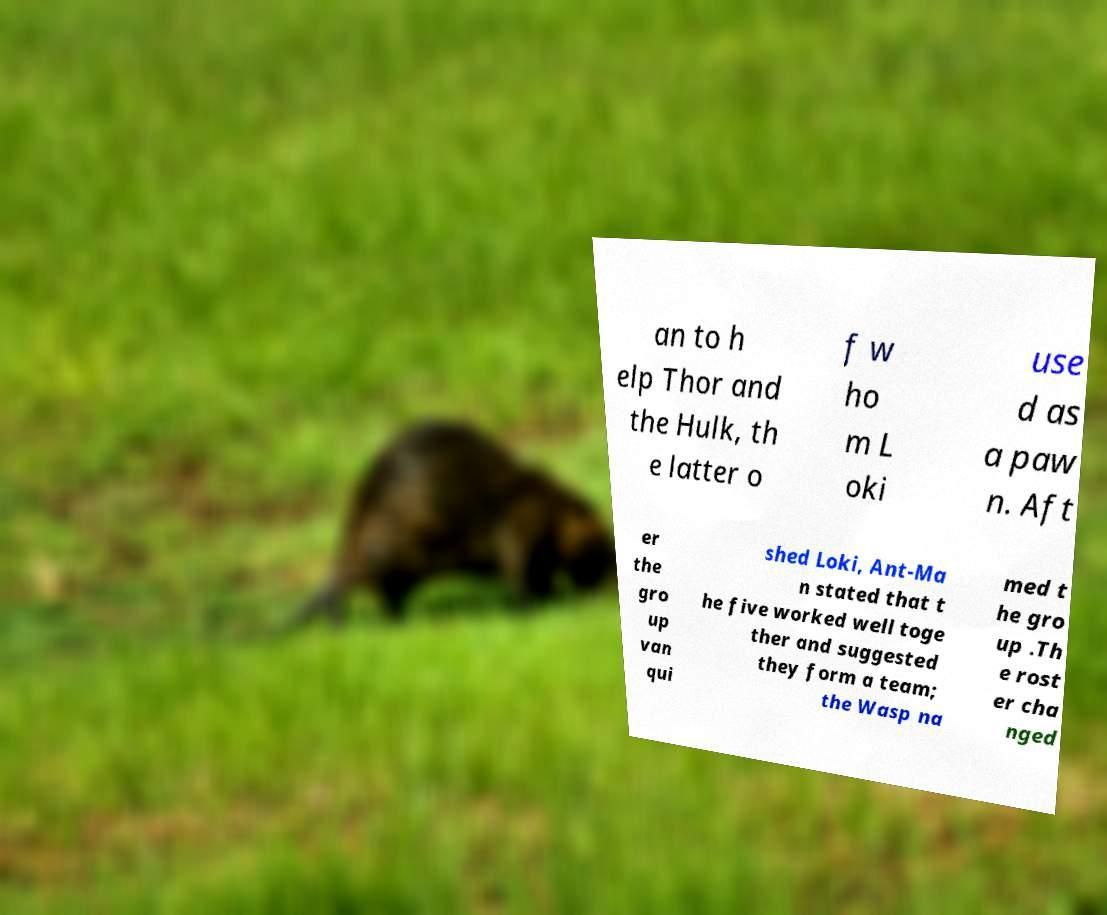For documentation purposes, I need the text within this image transcribed. Could you provide that? an to h elp Thor and the Hulk, th e latter o f w ho m L oki use d as a paw n. Aft er the gro up van qui shed Loki, Ant-Ma n stated that t he five worked well toge ther and suggested they form a team; the Wasp na med t he gro up .Th e rost er cha nged 